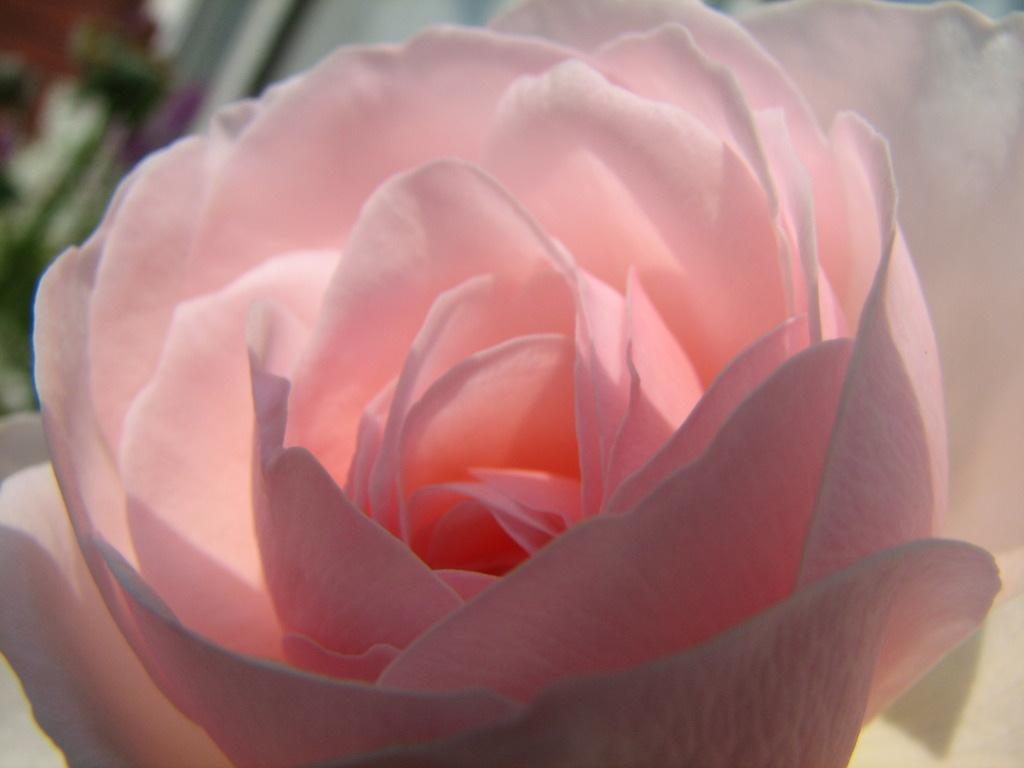What can be observed about the background of the image? The background of the image is blurred. What is the main subject of the image? There is a beautiful flower in the middle of the image. What color is the flower? The flower is light pink in color. What type of attraction is present in the image? There is no attraction present in the image; it features a light pink flower in the middle of a blurred background. Can you tell me where the stove is located in the image? There is no stove present in the image. 